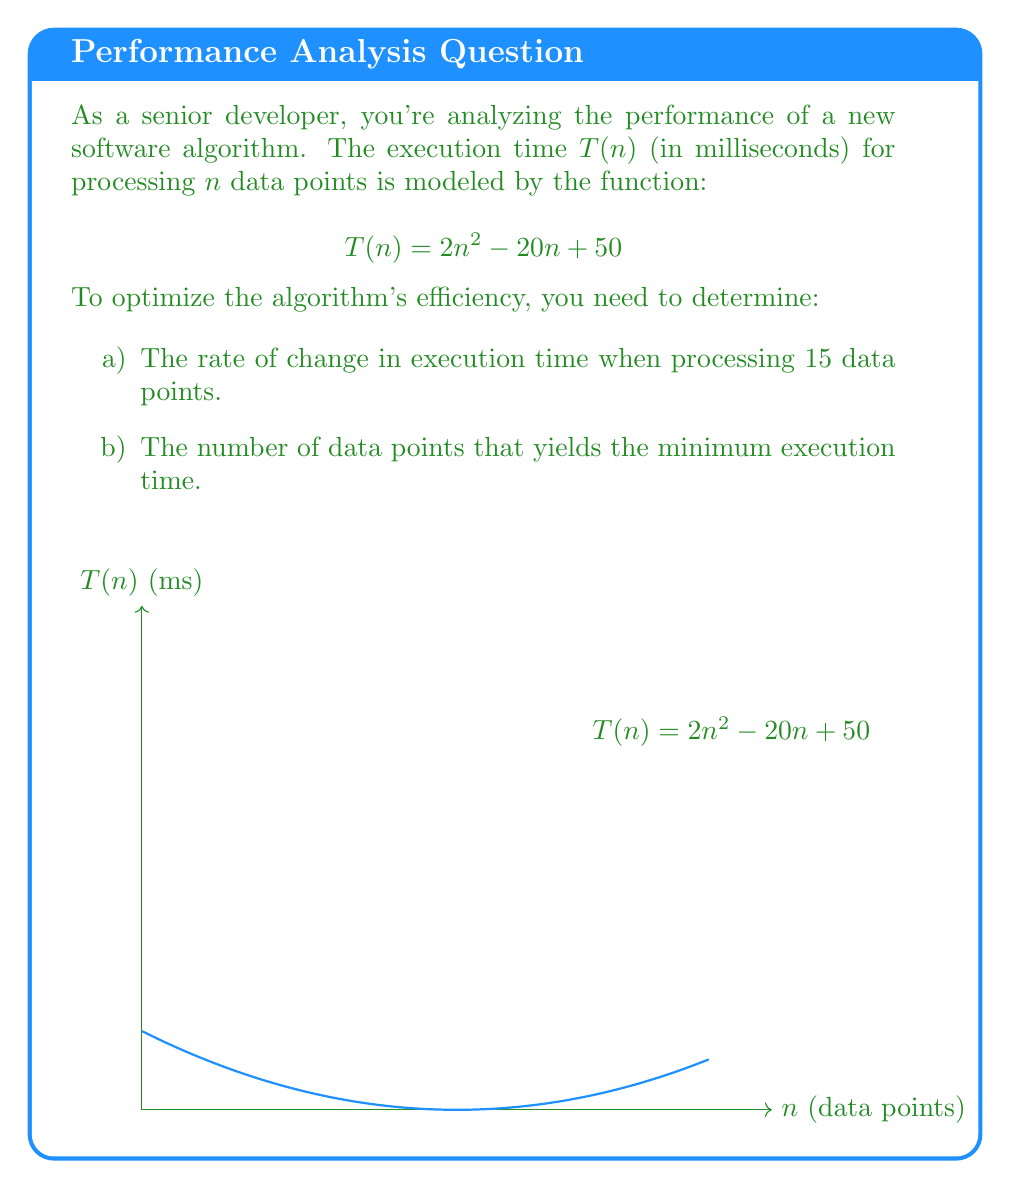Teach me how to tackle this problem. Let's approach this step-by-step:

a) To find the rate of change in execution time when processing 15 data points:

1. We need to find the derivative of $T(n)$:
   $$T'(n) = \frac{d}{dn}(2n^2 - 20n + 50) = 4n - 20$$

2. Now, we evaluate $T'(15)$:
   $$T'(15) = 4(15) - 20 = 60 - 20 = 40$$

This means the rate of change is 40 ms per data point when processing 15 data points.

b) To find the number of data points that yields the minimum execution time:

1. The minimum occurs where the derivative equals zero:
   $$T'(n) = 4n - 20 = 0$$

2. Solve for $n$:
   $$4n = 20$$
   $$n = 5$$

3. To confirm this is a minimum (not a maximum), we can check the second derivative:
   $$T''(n) = \frac{d}{dn}(4n - 20) = 4$$

   Since $T''(n) > 0$, this confirms a minimum.

Therefore, the execution time is minimized when processing 5 data points.
Answer: a) 40 ms/point
b) 5 data points 